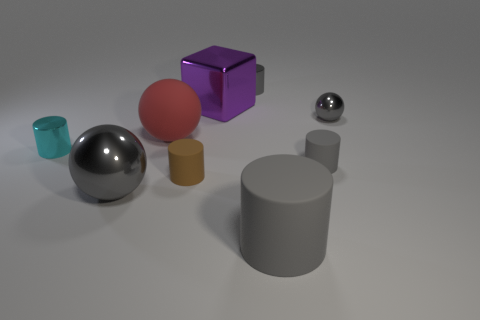Do the purple shiny thing and the metallic sphere that is in front of the cyan metallic object have the same size?
Your response must be concise. Yes. The small thing that is both in front of the red rubber thing and to the right of the big gray cylinder is what color?
Offer a very short reply. Gray. Is there a tiny thing behind the tiny metallic cylinder that is in front of the big red rubber ball?
Your response must be concise. Yes. Is the number of small gray things that are on the left side of the red sphere the same as the number of small green metallic cylinders?
Ensure brevity in your answer.  Yes. What number of big gray cylinders are to the left of the object that is to the left of the gray metal sphere in front of the cyan object?
Make the answer very short. 0. Is there a gray rubber cylinder of the same size as the brown matte cylinder?
Your answer should be compact. Yes. Is the number of tiny rubber objects right of the large purple shiny object less than the number of balls?
Offer a very short reply. Yes. There is a gray cylinder to the right of the matte cylinder in front of the big shiny thing in front of the large red ball; what is its material?
Ensure brevity in your answer.  Rubber. Is the number of big gray objects left of the tiny gray metallic sphere greater than the number of purple metallic things that are in front of the tiny cyan cylinder?
Ensure brevity in your answer.  Yes. How many rubber objects are gray cubes or small brown cylinders?
Your answer should be very brief. 1. 